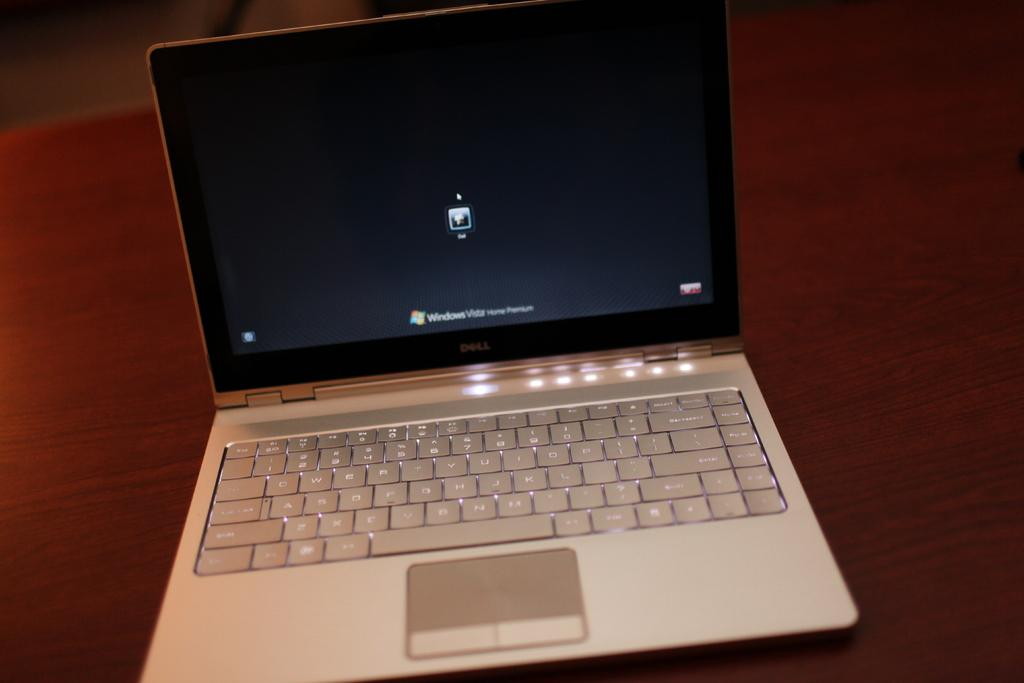Provide a one-sentence caption for the provided image. The login screen of a laptop with Windows operating system. 